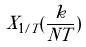Convert formula to latex. <formula><loc_0><loc_0><loc_500><loc_500>X _ { 1 / T } ( \frac { k } { N T } )</formula> 